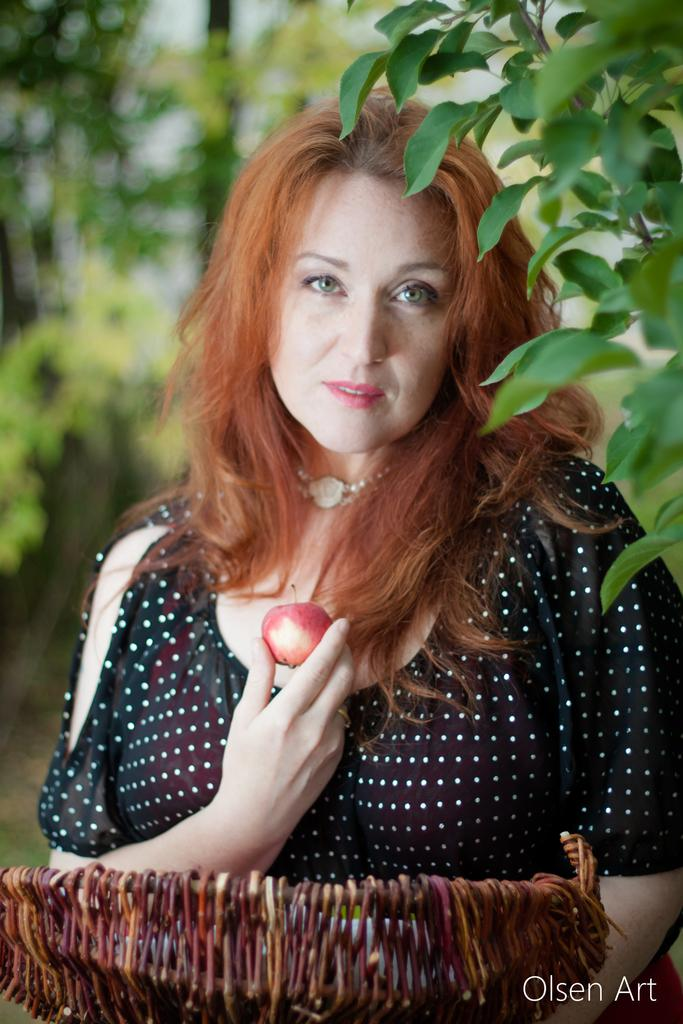Who is present in the image? There is a lady in the image. What is the lady holding in the image? The lady is holding a basket and a fruit. What can be seen in the background of the image? There are trees visible in the image. What type of burn can be seen on the lady's hand in the image? There is no burn visible on the lady's hand in the image. What type of pickle is the lady using to hold the fruit in the image? There is no pickle present in the image; the lady is holding a fruit with her hand. 